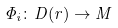<formula> <loc_0><loc_0><loc_500><loc_500>\Phi _ { i } \colon D ( r ) \to M</formula> 